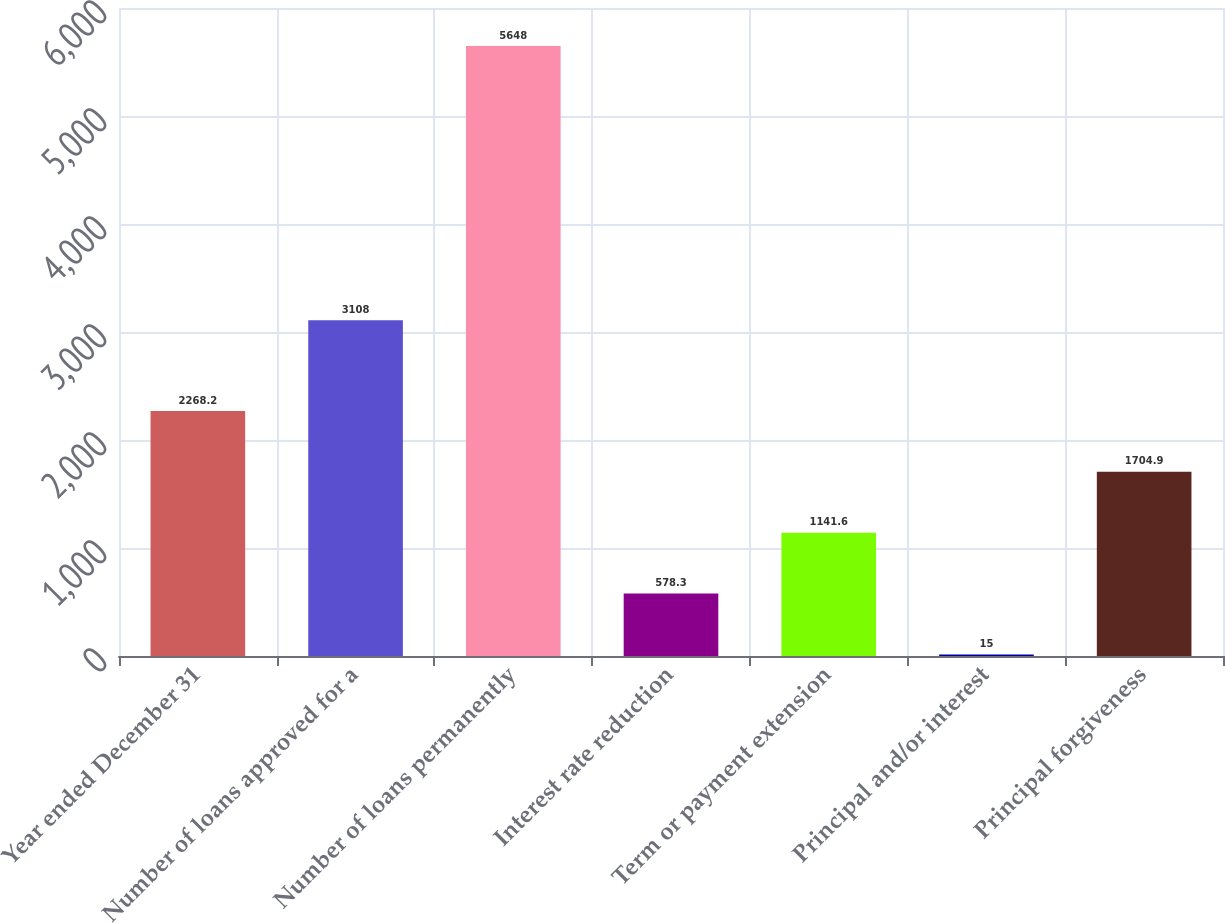Convert chart. <chart><loc_0><loc_0><loc_500><loc_500><bar_chart><fcel>Year ended December 31<fcel>Number of loans approved for a<fcel>Number of loans permanently<fcel>Interest rate reduction<fcel>Term or payment extension<fcel>Principal and/or interest<fcel>Principal forgiveness<nl><fcel>2268.2<fcel>3108<fcel>5648<fcel>578.3<fcel>1141.6<fcel>15<fcel>1704.9<nl></chart> 